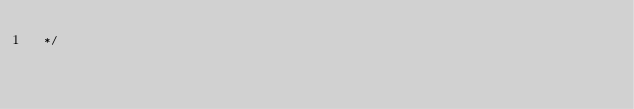<code> <loc_0><loc_0><loc_500><loc_500><_CSS_> */
</code> 